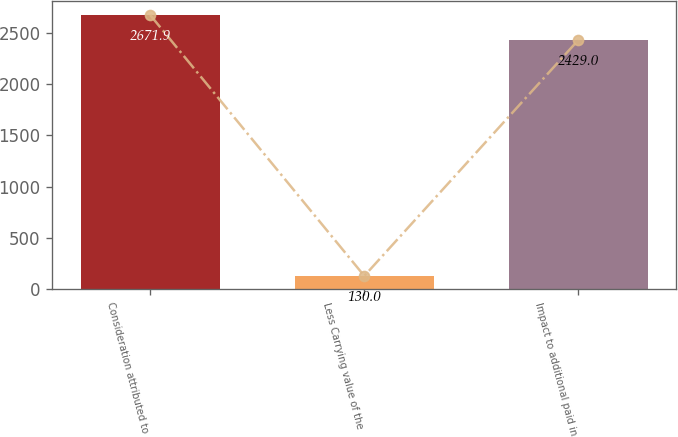<chart> <loc_0><loc_0><loc_500><loc_500><bar_chart><fcel>Consideration attributed to<fcel>Less Carrying value of the<fcel>Impact to additional paid in<nl><fcel>2671.9<fcel>130<fcel>2429<nl></chart> 